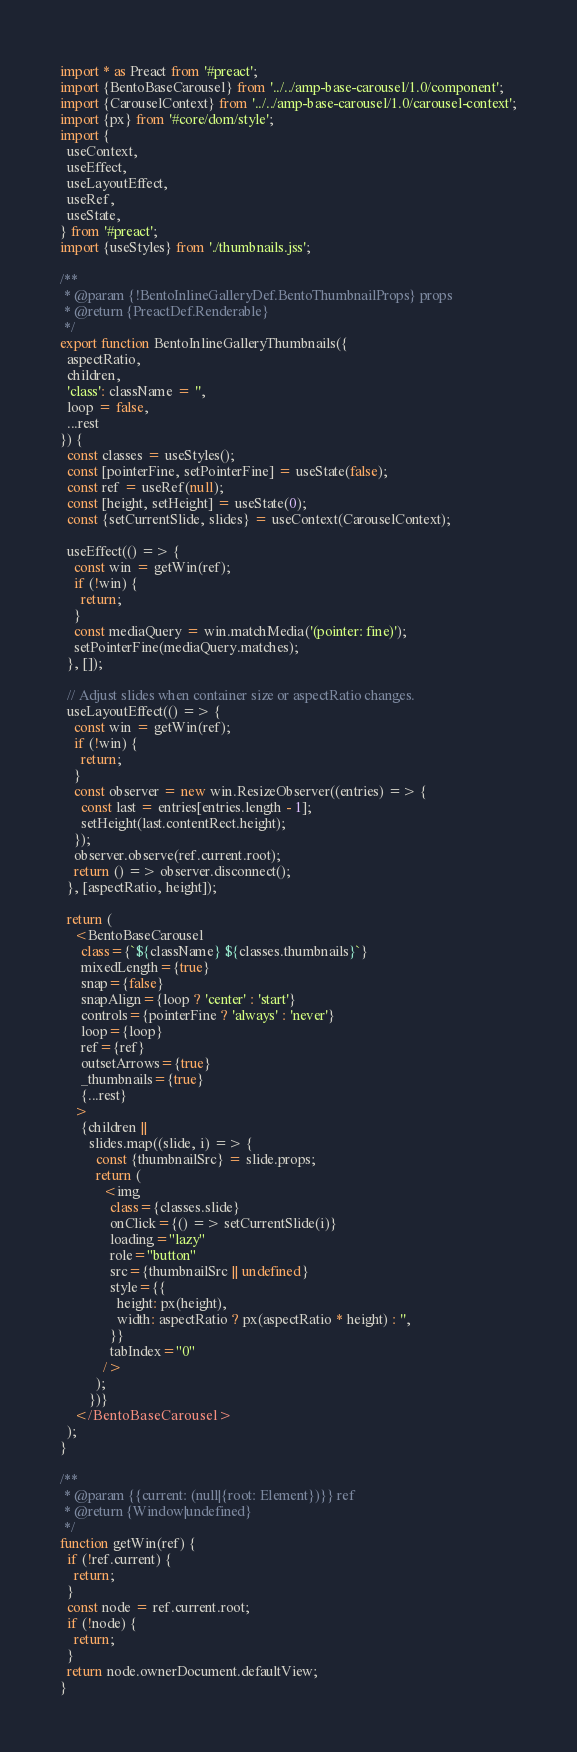<code> <loc_0><loc_0><loc_500><loc_500><_JavaScript_>import * as Preact from '#preact';
import {BentoBaseCarousel} from '../../amp-base-carousel/1.0/component';
import {CarouselContext} from '../../amp-base-carousel/1.0/carousel-context';
import {px} from '#core/dom/style';
import {
  useContext,
  useEffect,
  useLayoutEffect,
  useRef,
  useState,
} from '#preact';
import {useStyles} from './thumbnails.jss';

/**
 * @param {!BentoInlineGalleryDef.BentoThumbnailProps} props
 * @return {PreactDef.Renderable}
 */
export function BentoInlineGalleryThumbnails({
  aspectRatio,
  children,
  'class': className = '',
  loop = false,
  ...rest
}) {
  const classes = useStyles();
  const [pointerFine, setPointerFine] = useState(false);
  const ref = useRef(null);
  const [height, setHeight] = useState(0);
  const {setCurrentSlide, slides} = useContext(CarouselContext);

  useEffect(() => {
    const win = getWin(ref);
    if (!win) {
      return;
    }
    const mediaQuery = win.matchMedia('(pointer: fine)');
    setPointerFine(mediaQuery.matches);
  }, []);

  // Adjust slides when container size or aspectRatio changes.
  useLayoutEffect(() => {
    const win = getWin(ref);
    if (!win) {
      return;
    }
    const observer = new win.ResizeObserver((entries) => {
      const last = entries[entries.length - 1];
      setHeight(last.contentRect.height);
    });
    observer.observe(ref.current.root);
    return () => observer.disconnect();
  }, [aspectRatio, height]);

  return (
    <BentoBaseCarousel
      class={`${className} ${classes.thumbnails}`}
      mixedLength={true}
      snap={false}
      snapAlign={loop ? 'center' : 'start'}
      controls={pointerFine ? 'always' : 'never'}
      loop={loop}
      ref={ref}
      outsetArrows={true}
      _thumbnails={true}
      {...rest}
    >
      {children ||
        slides.map((slide, i) => {
          const {thumbnailSrc} = slide.props;
          return (
            <img
              class={classes.slide}
              onClick={() => setCurrentSlide(i)}
              loading="lazy"
              role="button"
              src={thumbnailSrc || undefined}
              style={{
                height: px(height),
                width: aspectRatio ? px(aspectRatio * height) : '',
              }}
              tabIndex="0"
            />
          );
        })}
    </BentoBaseCarousel>
  );
}

/**
 * @param {{current: (null|{root: Element})}} ref
 * @return {Window|undefined}
 */
function getWin(ref) {
  if (!ref.current) {
    return;
  }
  const node = ref.current.root;
  if (!node) {
    return;
  }
  return node.ownerDocument.defaultView;
}
</code> 